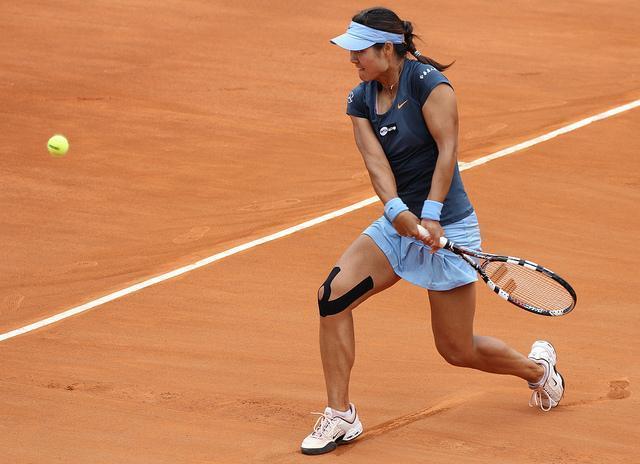How many pizza is there?
Give a very brief answer. 0. 